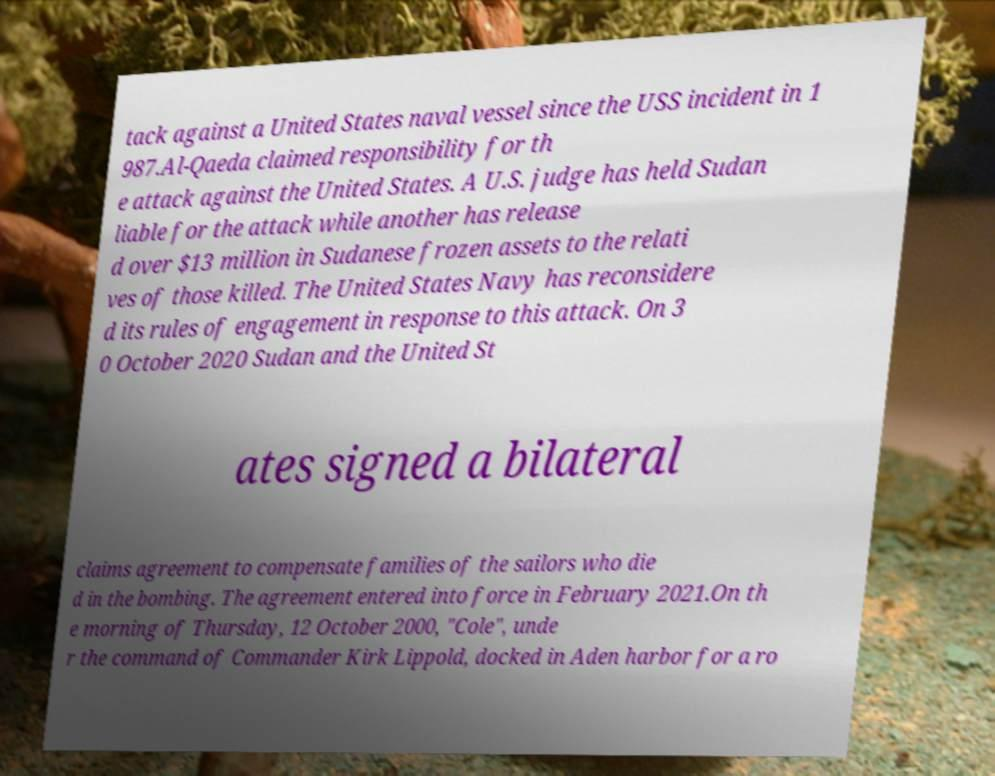For documentation purposes, I need the text within this image transcribed. Could you provide that? tack against a United States naval vessel since the USS incident in 1 987.Al-Qaeda claimed responsibility for th e attack against the United States. A U.S. judge has held Sudan liable for the attack while another has release d over $13 million in Sudanese frozen assets to the relati ves of those killed. The United States Navy has reconsidere d its rules of engagement in response to this attack. On 3 0 October 2020 Sudan and the United St ates signed a bilateral claims agreement to compensate families of the sailors who die d in the bombing. The agreement entered into force in February 2021.On th e morning of Thursday, 12 October 2000, "Cole", unde r the command of Commander Kirk Lippold, docked in Aden harbor for a ro 